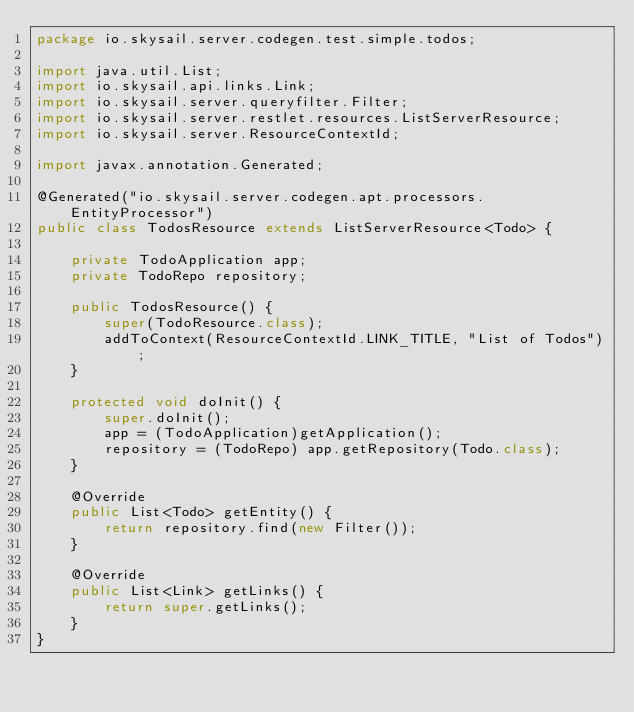<code> <loc_0><loc_0><loc_500><loc_500><_Java_>package io.skysail.server.codegen.test.simple.todos;

import java.util.List;
import io.skysail.api.links.Link;
import io.skysail.server.queryfilter.Filter;
import io.skysail.server.restlet.resources.ListServerResource;
import io.skysail.server.ResourceContextId;

import javax.annotation.Generated;

@Generated("io.skysail.server.codegen.apt.processors.EntityProcessor")
public class TodosResource extends ListServerResource<Todo> {

    private TodoApplication app;
    private TodoRepo repository;

    public TodosResource() {
        super(TodoResource.class);
        addToContext(ResourceContextId.LINK_TITLE, "List of Todos");
    }

    protected void doInit() {
        super.doInit();
        app = (TodoApplication)getApplication();
        repository = (TodoRepo) app.getRepository(Todo.class);
    }

    @Override
    public List<Todo> getEntity() {
        return repository.find(new Filter());
    }

    @Override
    public List<Link> getLinks() {
        return super.getLinks();
    }
}
</code> 